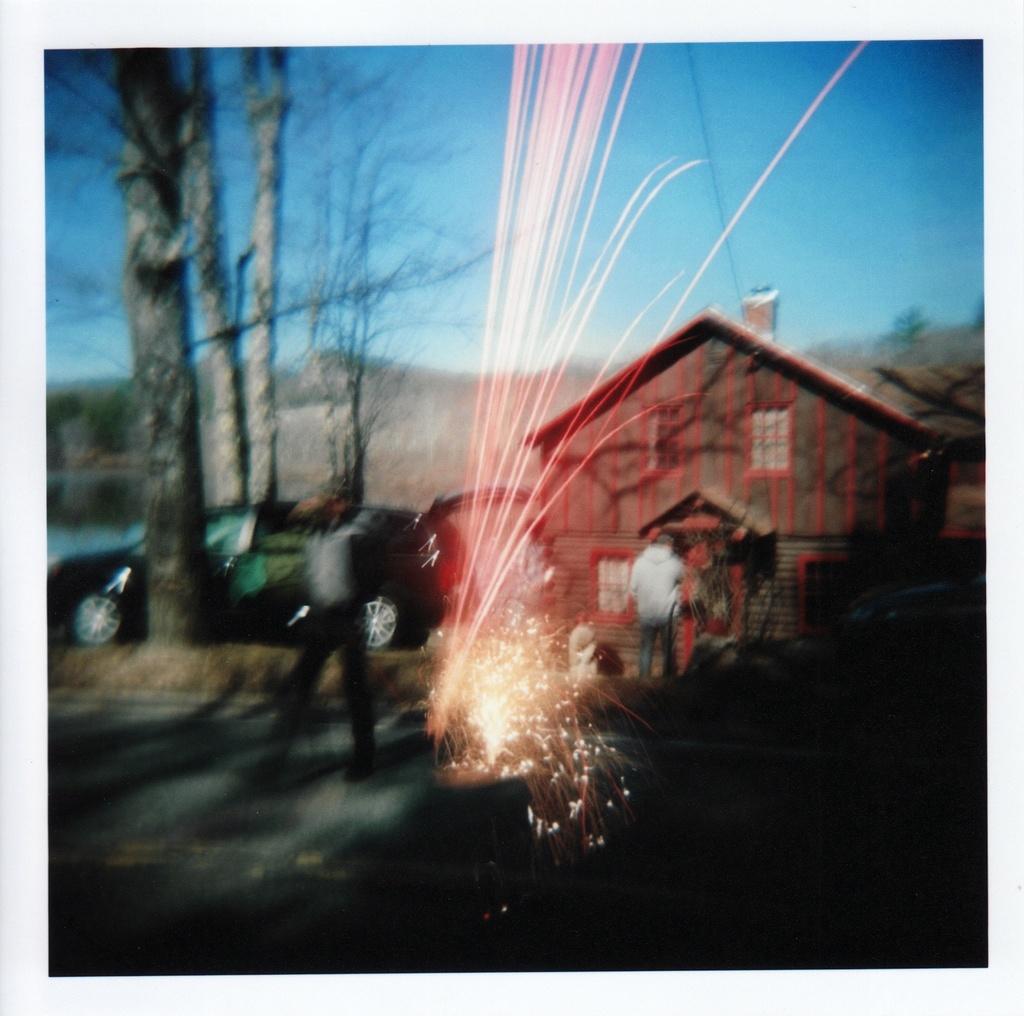Describe this image in one or two sentences. It is the blur image in which there is a person walking on the road. In the background there is a house. Beside the house there is a car. There are trees on either side of the car. There is a sparkle in the middle. At the top there is the sky. 